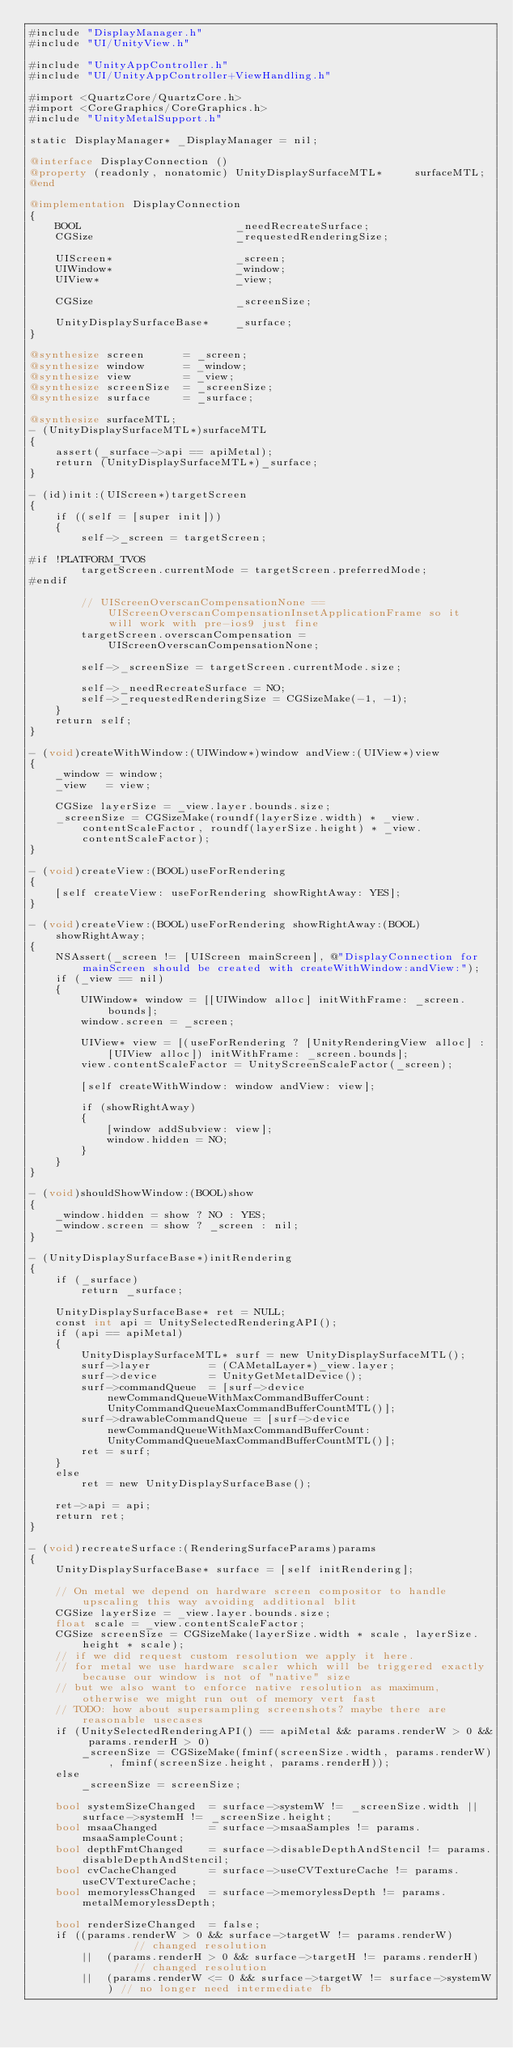<code> <loc_0><loc_0><loc_500><loc_500><_ObjectiveC_>#include "DisplayManager.h"
#include "UI/UnityView.h"

#include "UnityAppController.h"
#include "UI/UnityAppController+ViewHandling.h"

#import <QuartzCore/QuartzCore.h>
#import <CoreGraphics/CoreGraphics.h>
#include "UnityMetalSupport.h"

static DisplayManager* _DisplayManager = nil;

@interface DisplayConnection ()
@property (readonly, nonatomic) UnityDisplaySurfaceMTL*     surfaceMTL;
@end

@implementation DisplayConnection
{
    BOOL                        _needRecreateSurface;
    CGSize                      _requestedRenderingSize;

    UIScreen*                   _screen;
    UIWindow*                   _window;
    UIView*                     _view;

    CGSize                      _screenSize;

    UnityDisplaySurfaceBase*    _surface;
}

@synthesize screen      = _screen;
@synthesize window      = _window;
@synthesize view        = _view;
@synthesize screenSize  = _screenSize;
@synthesize surface     = _surface;

@synthesize surfaceMTL;
- (UnityDisplaySurfaceMTL*)surfaceMTL
{
    assert(_surface->api == apiMetal);
    return (UnityDisplaySurfaceMTL*)_surface;
}

- (id)init:(UIScreen*)targetScreen
{
    if ((self = [super init]))
    {
        self->_screen = targetScreen;

#if !PLATFORM_TVOS
        targetScreen.currentMode = targetScreen.preferredMode;
#endif

        // UIScreenOverscanCompensationNone == UIScreenOverscanCompensationInsetApplicationFrame so it will work with pre-ios9 just fine
        targetScreen.overscanCompensation = UIScreenOverscanCompensationNone;

        self->_screenSize = targetScreen.currentMode.size;

        self->_needRecreateSurface = NO;
        self->_requestedRenderingSize = CGSizeMake(-1, -1);
    }
    return self;
}

- (void)createWithWindow:(UIWindow*)window andView:(UIView*)view
{
    _window = window;
    _view   = view;

    CGSize layerSize = _view.layer.bounds.size;
    _screenSize = CGSizeMake(roundf(layerSize.width) * _view.contentScaleFactor, roundf(layerSize.height) * _view.contentScaleFactor);
}

- (void)createView:(BOOL)useForRendering
{
    [self createView: useForRendering showRightAway: YES];
}

- (void)createView:(BOOL)useForRendering showRightAway:(BOOL)showRightAway;
{
    NSAssert(_screen != [UIScreen mainScreen], @"DisplayConnection for mainScreen should be created with createWithWindow:andView:");
    if (_view == nil)
    {
        UIWindow* window = [[UIWindow alloc] initWithFrame: _screen.bounds];
        window.screen = _screen;

        UIView* view = [(useForRendering ? [UnityRenderingView alloc] : [UIView alloc]) initWithFrame: _screen.bounds];
        view.contentScaleFactor = UnityScreenScaleFactor(_screen);

        [self createWithWindow: window andView: view];

        if (showRightAway)
        {
            [window addSubview: view];
            window.hidden = NO;
        }
    }
}

- (void)shouldShowWindow:(BOOL)show
{
    _window.hidden = show ? NO : YES;
    _window.screen = show ? _screen : nil;
}

- (UnityDisplaySurfaceBase*)initRendering
{
    if (_surface)
        return _surface;

    UnityDisplaySurfaceBase* ret = NULL;
    const int api = UnitySelectedRenderingAPI();
    if (api == apiMetal)
    {
        UnityDisplaySurfaceMTL* surf = new UnityDisplaySurfaceMTL();
        surf->layer         = (CAMetalLayer*)_view.layer;
        surf->device        = UnityGetMetalDevice();
        surf->commandQueue  = [surf->device newCommandQueueWithMaxCommandBufferCount: UnityCommandQueueMaxCommandBufferCountMTL()];
        surf->drawableCommandQueue = [surf->device newCommandQueueWithMaxCommandBufferCount: UnityCommandQueueMaxCommandBufferCountMTL()];
        ret = surf;
    }
    else
        ret = new UnityDisplaySurfaceBase();

    ret->api = api;
    return ret;
}

- (void)recreateSurface:(RenderingSurfaceParams)params
{
    UnityDisplaySurfaceBase* surface = [self initRendering];

    // On metal we depend on hardware screen compositor to handle upscaling this way avoiding additional blit
    CGSize layerSize = _view.layer.bounds.size;
    float scale = _view.contentScaleFactor;
    CGSize screenSize = CGSizeMake(layerSize.width * scale, layerSize.height * scale);
    // if we did request custom resolution we apply it here.
    // for metal we use hardware scaler which will be triggered exactly because our window is not of "native" size
    // but we also want to enforce native resolution as maximum, otherwise we might run out of memory vert fast
    // TODO: how about supersampling screenshots? maybe there are reasonable usecases
    if (UnitySelectedRenderingAPI() == apiMetal && params.renderW > 0 && params.renderH > 0)
        _screenSize = CGSizeMake(fminf(screenSize.width, params.renderW), fminf(screenSize.height, params.renderH));
    else
        _screenSize = screenSize;

    bool systemSizeChanged  = surface->systemW != _screenSize.width || surface->systemH != _screenSize.height;
    bool msaaChanged        = surface->msaaSamples != params.msaaSampleCount;
    bool depthFmtChanged    = surface->disableDepthAndStencil != params.disableDepthAndStencil;
    bool cvCacheChanged     = surface->useCVTextureCache != params.useCVTextureCache;
    bool memorylessChanged  = surface->memorylessDepth != params.metalMemorylessDepth;

    bool renderSizeChanged  = false;
    if ((params.renderW > 0 && surface->targetW != params.renderW)         // changed resolution
        ||  (params.renderH > 0 && surface->targetH != params.renderH)     // changed resolution
        ||  (params.renderW <= 0 && surface->targetW != surface->systemW) // no longer need intermediate fb</code> 